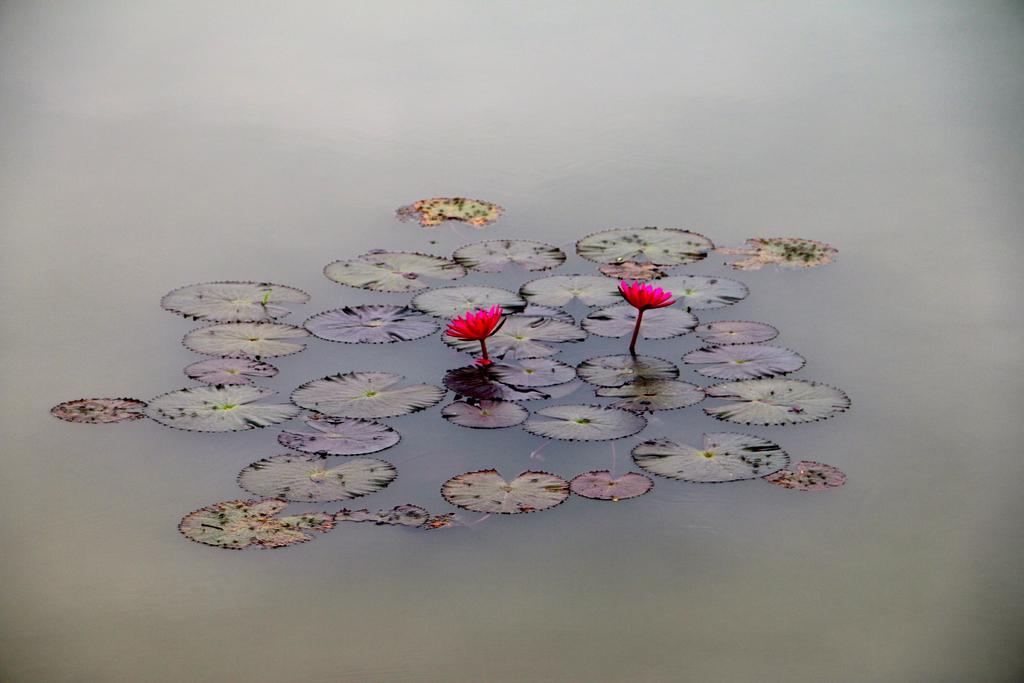In one or two sentences, can you explain what this image depicts? In this image there are two flowers and some leaves in the water. 